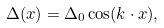Convert formula to latex. <formula><loc_0><loc_0><loc_500><loc_500>\Delta ( x ) = \Delta _ { 0 } \cos ( k \cdot x ) ,</formula> 